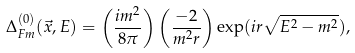Convert formula to latex. <formula><loc_0><loc_0><loc_500><loc_500>\Delta _ { F m } ^ { ( 0 ) } ( \vec { x } , E ) = \left ( \frac { i m ^ { 2 } } { 8 \pi } \right ) \left ( \frac { - 2 } { m ^ { 2 } r } \right ) \exp ( i r \sqrt { E ^ { 2 } - m ^ { 2 } } ) ,</formula> 